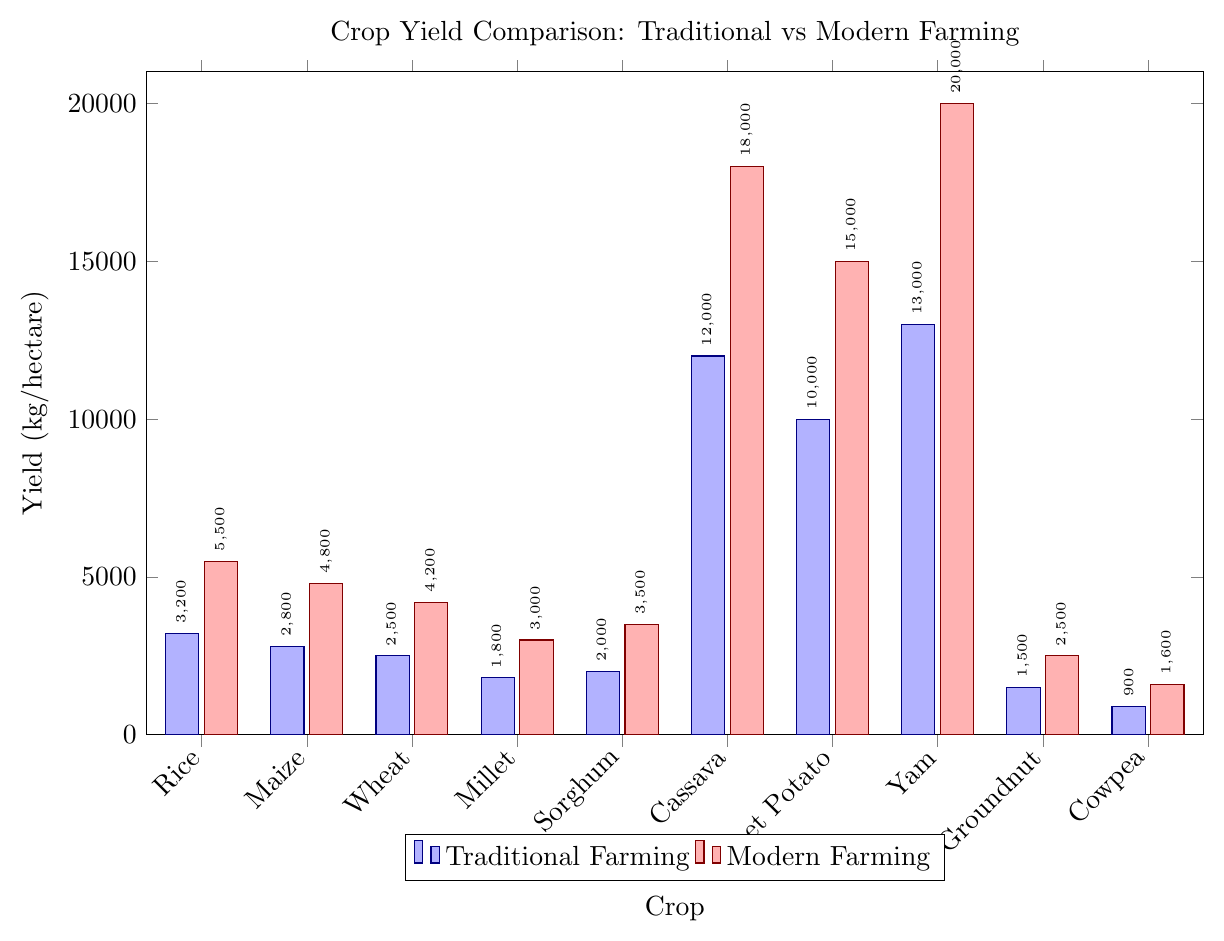Which crop has the highest traditional yield? Observing the tallest blue bar among all the crops would indicate the crop with the highest traditional yield. The tallest blue bar corresponds to Yam at 13000 kg/hectare.
Answer: Yam Compare the yields of Rice in traditional and modern farming methods. By looking at the height of the bars for Rice under both farming methods, the blue bar (Traditional) reaches 3200 kg/hectare while the red bar (Modern) reaches 5500 kg/hectare.
Answer: 3200 kg/hectare (Traditional), 5500 kg/hectare (Modern) Which crop shows the smallest difference in yield between traditional and modern farming methods? To find the smallest difference, visually compare the gap between the blue and red bars for each crop. Groundnut shows the smallest difference with traditional yield at 1500 kg/hectare and modern yield at 2500 kg/hectare, resulting in a difference of 1000 kg/hectare.
Answer: Groundnut On average, how much higher is the yield of modern farming compared to traditional farming for all crops? Compute the average yields for both methods and then find the difference. Total traditional yield: 3200 + 2800 + 2500 + 1800 + 2000 + 12000 + 10000 + 13000 + 1500 + 900 = 48900. Total modern yield: 5500 + 4800 + 4200 + 3000 + 3500 + 18000 + 15000 + 20000 + 2500 + 1600 = 74100. Average traditional yield: 48900 / 10 = 4890. Average modern yield: 74100 / 10 = 7410. Difference: 7410 - 4890 = 2520.
Answer: 2520 kg/hectare Identify the two crops with the highest yield increase when shifting from traditional to modern farming. Observe the gap between the blue and red bars for each crop and identify the largest gaps. Yam has the highest increase (7000 kg/hectare), followed by Cassava (6000 kg/hectare).
Answer: Yam and Cassava For which crops are modern farming yields at least twice the traditional yields? Check if the red bar is at least twice the height of the blue bar for each crop. Crops where this condition holds are Maize (2800 -> 4800), Wheat (2500 -> 4200), Millet (1800 -> 3000), Sorghum (2000 -> 3500).
Answer: Maize, Wheat, Millet, Sorghum Which crop has the lowest yield in both traditional and modern methods? Identify the crop with the shortest bars in both blue and red. Cowpea shows the shortest bars with 900 kg/hectare in traditional and 1600 kg/hectare in modern farming.
Answer: Cowpea By what percentage does the yield of Cassava increase when using modern farming methods instead of traditional ones? Calculate the percentage increase: ((modern yield - traditional yield) / traditional yield) * 100. For Cassava: ((18000 - 12000) / 12000) * 100 = 50%.
Answer: 50% How much higher is the yield of modern Sweet Potato compared to traditional Sweet Potato? Subtract the traditional yield from the modern yield for Sweet Potato. Modern Sweet Potato yield is 15000 kg/hectare and traditional yield is 10000 kg/hectare. Difference: 15000 - 10000 = 5000 kg/hectare.
Answer: 5000 kg/hectare 